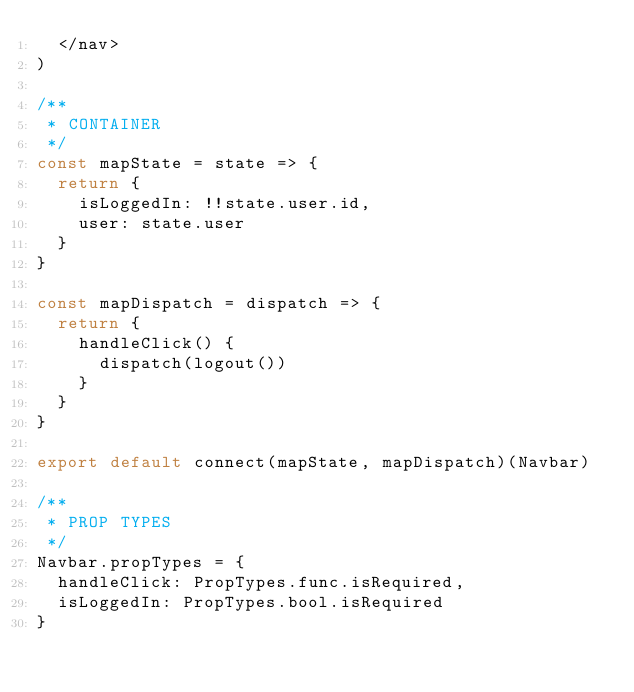<code> <loc_0><loc_0><loc_500><loc_500><_JavaScript_>  </nav>
)

/**
 * CONTAINER
 */
const mapState = state => {
  return {
    isLoggedIn: !!state.user.id,
    user: state.user
  }
}

const mapDispatch = dispatch => {
  return {
    handleClick() {
      dispatch(logout())
    }
  }
}

export default connect(mapState, mapDispatch)(Navbar)

/**
 * PROP TYPES
 */
Navbar.propTypes = {
  handleClick: PropTypes.func.isRequired,
  isLoggedIn: PropTypes.bool.isRequired
}
</code> 